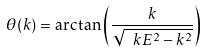Convert formula to latex. <formula><loc_0><loc_0><loc_500><loc_500>\theta ( k ) = \arctan \left ( \frac { k } { \sqrt { \ k E ^ { 2 } - k ^ { 2 } } } \right )</formula> 